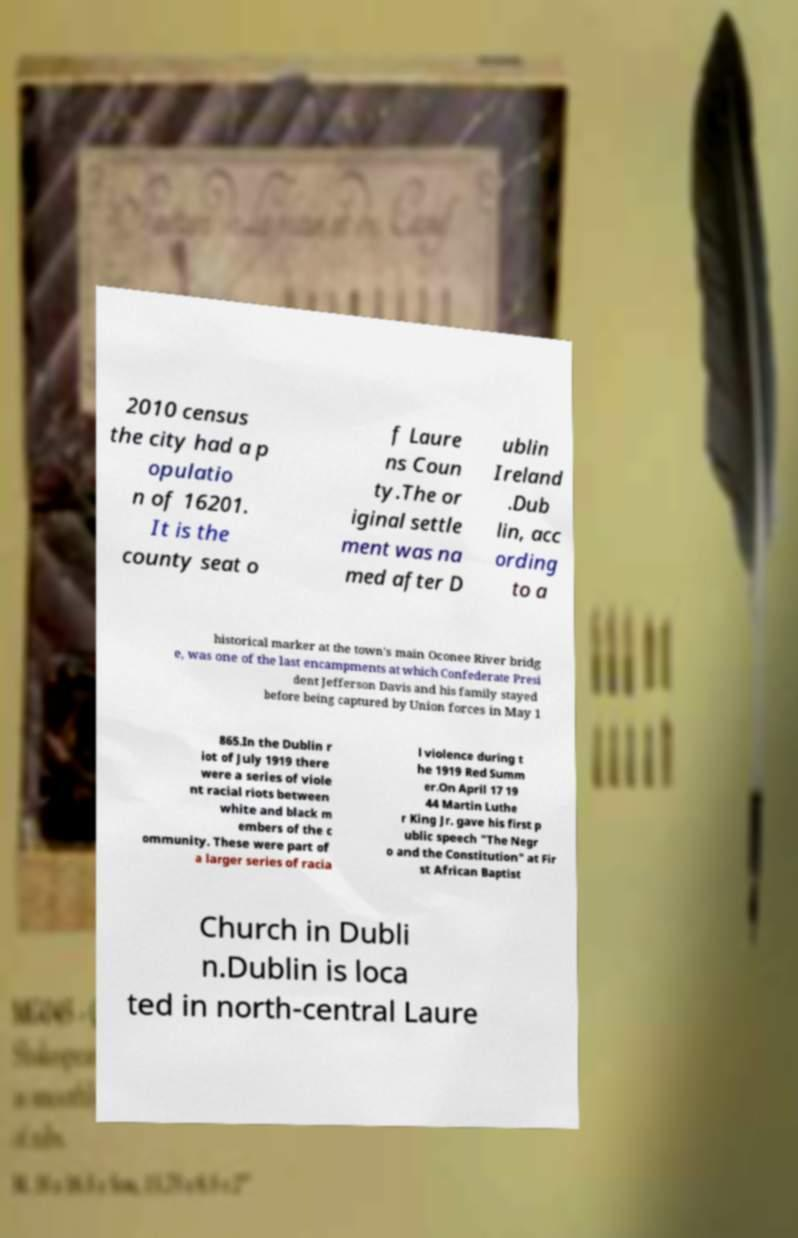Could you assist in decoding the text presented in this image and type it out clearly? 2010 census the city had a p opulatio n of 16201. It is the county seat o f Laure ns Coun ty.The or iginal settle ment was na med after D ublin Ireland .Dub lin, acc ording to a historical marker at the town's main Oconee River bridg e, was one of the last encampments at which Confederate Presi dent Jefferson Davis and his family stayed before being captured by Union forces in May 1 865.In the Dublin r iot of July 1919 there were a series of viole nt racial riots between white and black m embers of the c ommunity. These were part of a larger series of racia l violence during t he 1919 Red Summ er.On April 17 19 44 Martin Luthe r King Jr. gave his first p ublic speech "The Negr o and the Constitution" at Fir st African Baptist Church in Dubli n.Dublin is loca ted in north-central Laure 